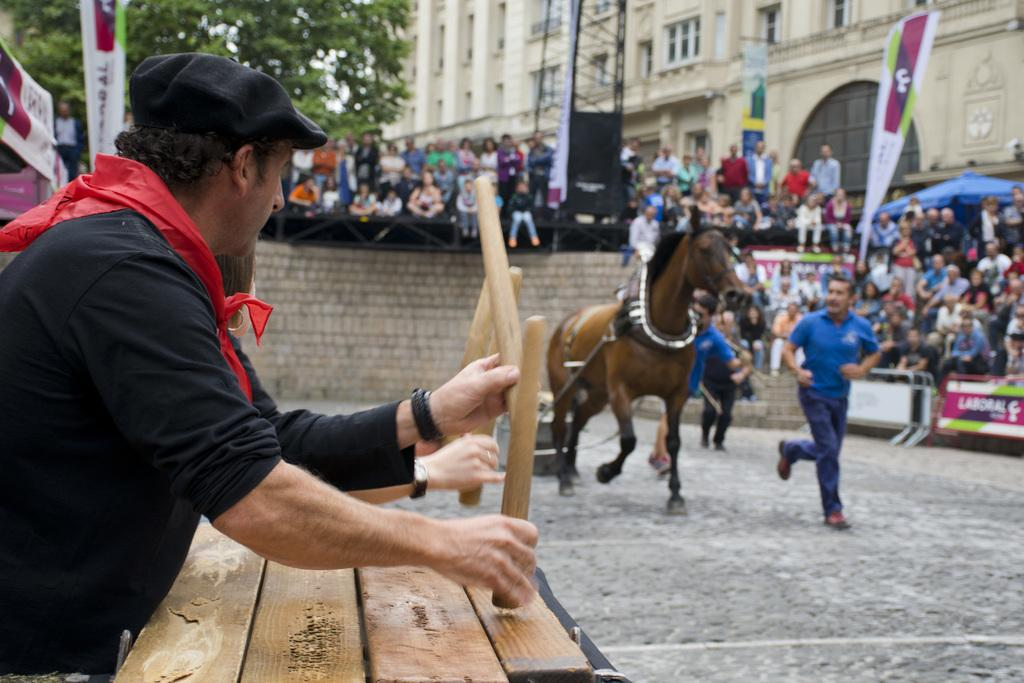What is the man holding in the image? There is a man holding a thing in the image. What animal is present in the image? There is a horse in the image. Can you describe the position of the second man in the image? There is another man behind the horse in the image. Are there any other people visible in the image? Yes, there are people behind the man and the horse in the image. What type of worm is the queen riding in the image? There is no worm or queen present in the image. 